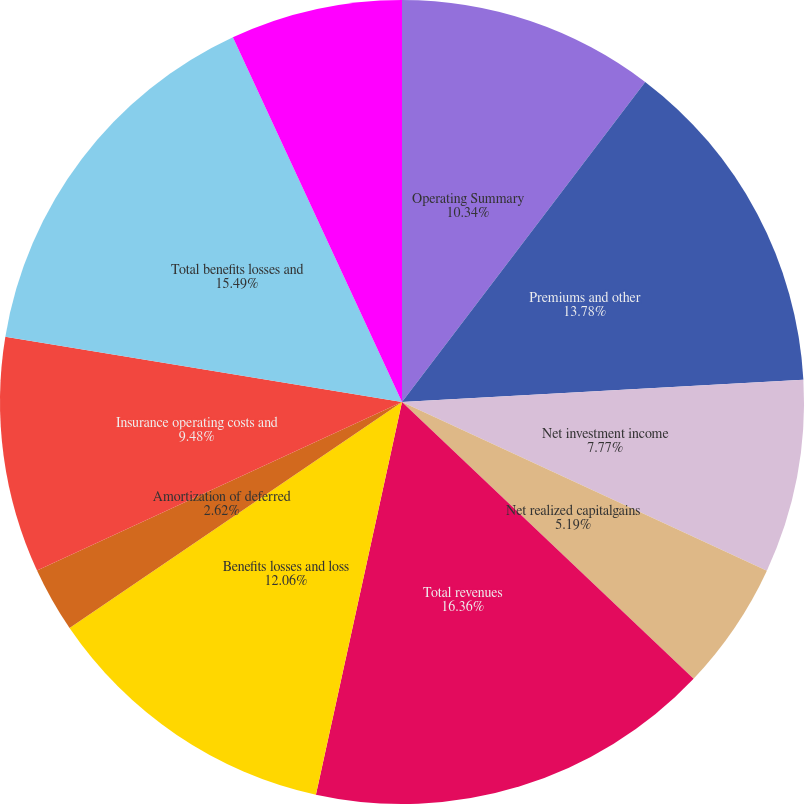Convert chart. <chart><loc_0><loc_0><loc_500><loc_500><pie_chart><fcel>Operating Summary<fcel>Premiums and other<fcel>Net investment income<fcel>Net realized capitalgains<fcel>Total revenues<fcel>Benefits losses and loss<fcel>Amortization of deferred<fcel>Insurance operating costs and<fcel>Total benefits losses and<fcel>Income before income taxes<nl><fcel>10.34%<fcel>13.78%<fcel>7.77%<fcel>5.19%<fcel>16.35%<fcel>12.06%<fcel>2.62%<fcel>9.48%<fcel>15.49%<fcel>6.91%<nl></chart> 